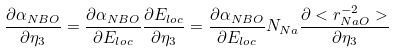Convert formula to latex. <formula><loc_0><loc_0><loc_500><loc_500>\frac { \partial \alpha _ { N B O } } { \partial \eta _ { 3 } } = \frac { \partial \alpha _ { N B O } } { \partial E _ { l o c } } \frac { \partial E _ { l o c } } { \partial \eta _ { 3 } } = \frac { \partial \alpha _ { N B O } } { \partial E _ { l o c } } N _ { N a } \frac { \partial < r ^ { - 2 } _ { N a O } > } { \partial \eta _ { 3 } }</formula> 